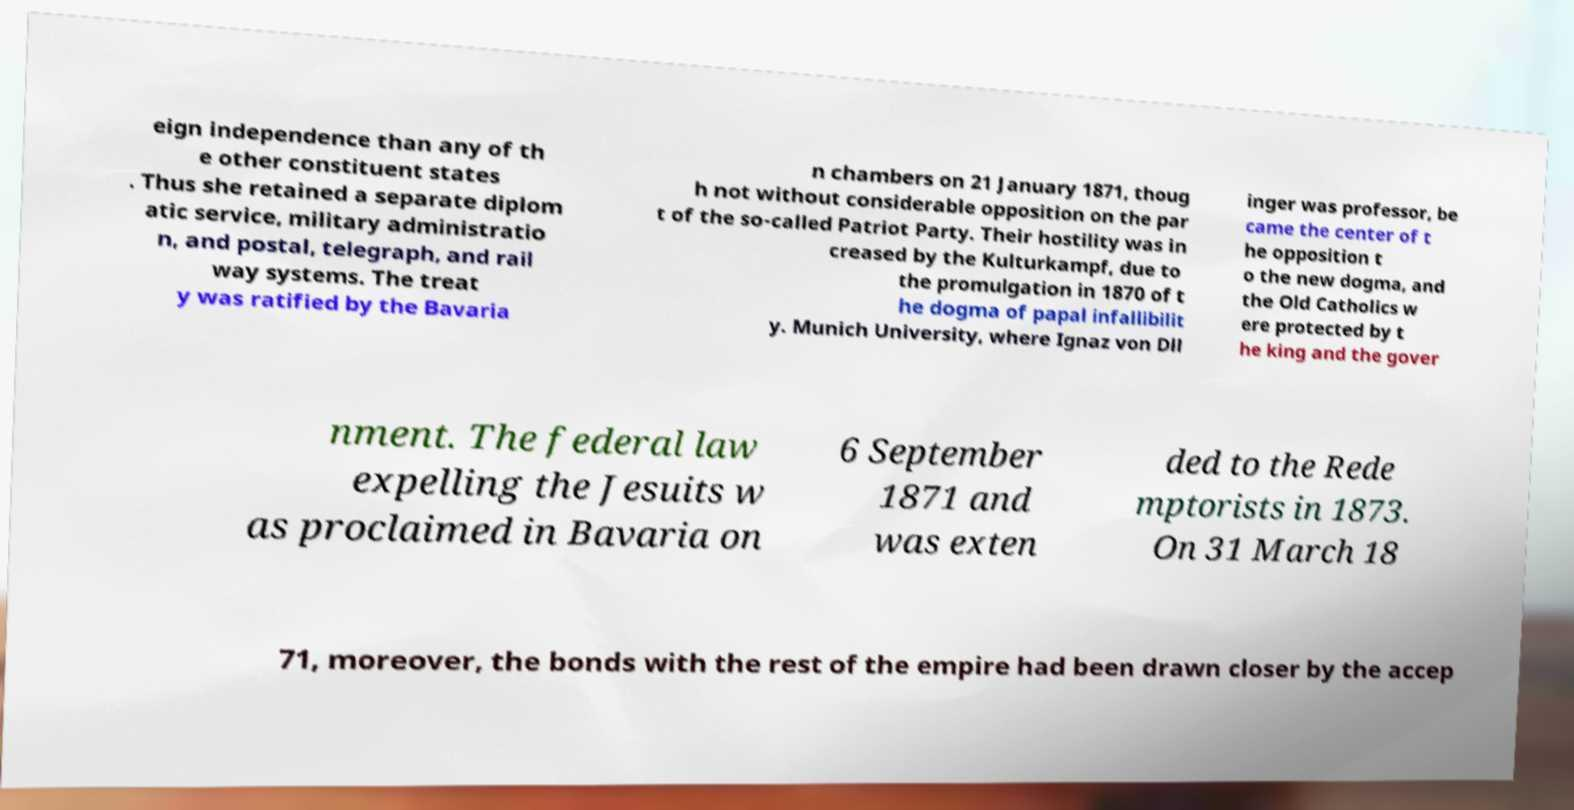Please identify and transcribe the text found in this image. eign independence than any of th e other constituent states . Thus she retained a separate diplom atic service, military administratio n, and postal, telegraph, and rail way systems. The treat y was ratified by the Bavaria n chambers on 21 January 1871, thoug h not without considerable opposition on the par t of the so-called Patriot Party. Their hostility was in creased by the Kulturkampf, due to the promulgation in 1870 of t he dogma of papal infallibilit y. Munich University, where Ignaz von Dll inger was professor, be came the center of t he opposition t o the new dogma, and the Old Catholics w ere protected by t he king and the gover nment. The federal law expelling the Jesuits w as proclaimed in Bavaria on 6 September 1871 and was exten ded to the Rede mptorists in 1873. On 31 March 18 71, moreover, the bonds with the rest of the empire had been drawn closer by the accep 